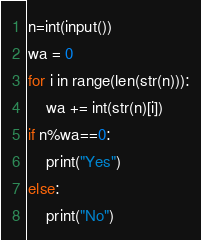<code> <loc_0><loc_0><loc_500><loc_500><_Python_>n=int(input())
wa = 0
for i in range(len(str(n))):
    wa += int(str(n)[i])
if n%wa==0:
    print("Yes")
else:
    print("No")</code> 